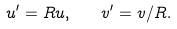Convert formula to latex. <formula><loc_0><loc_0><loc_500><loc_500>u ^ { \prime } = R u , \quad v ^ { \prime } = v / R .</formula> 